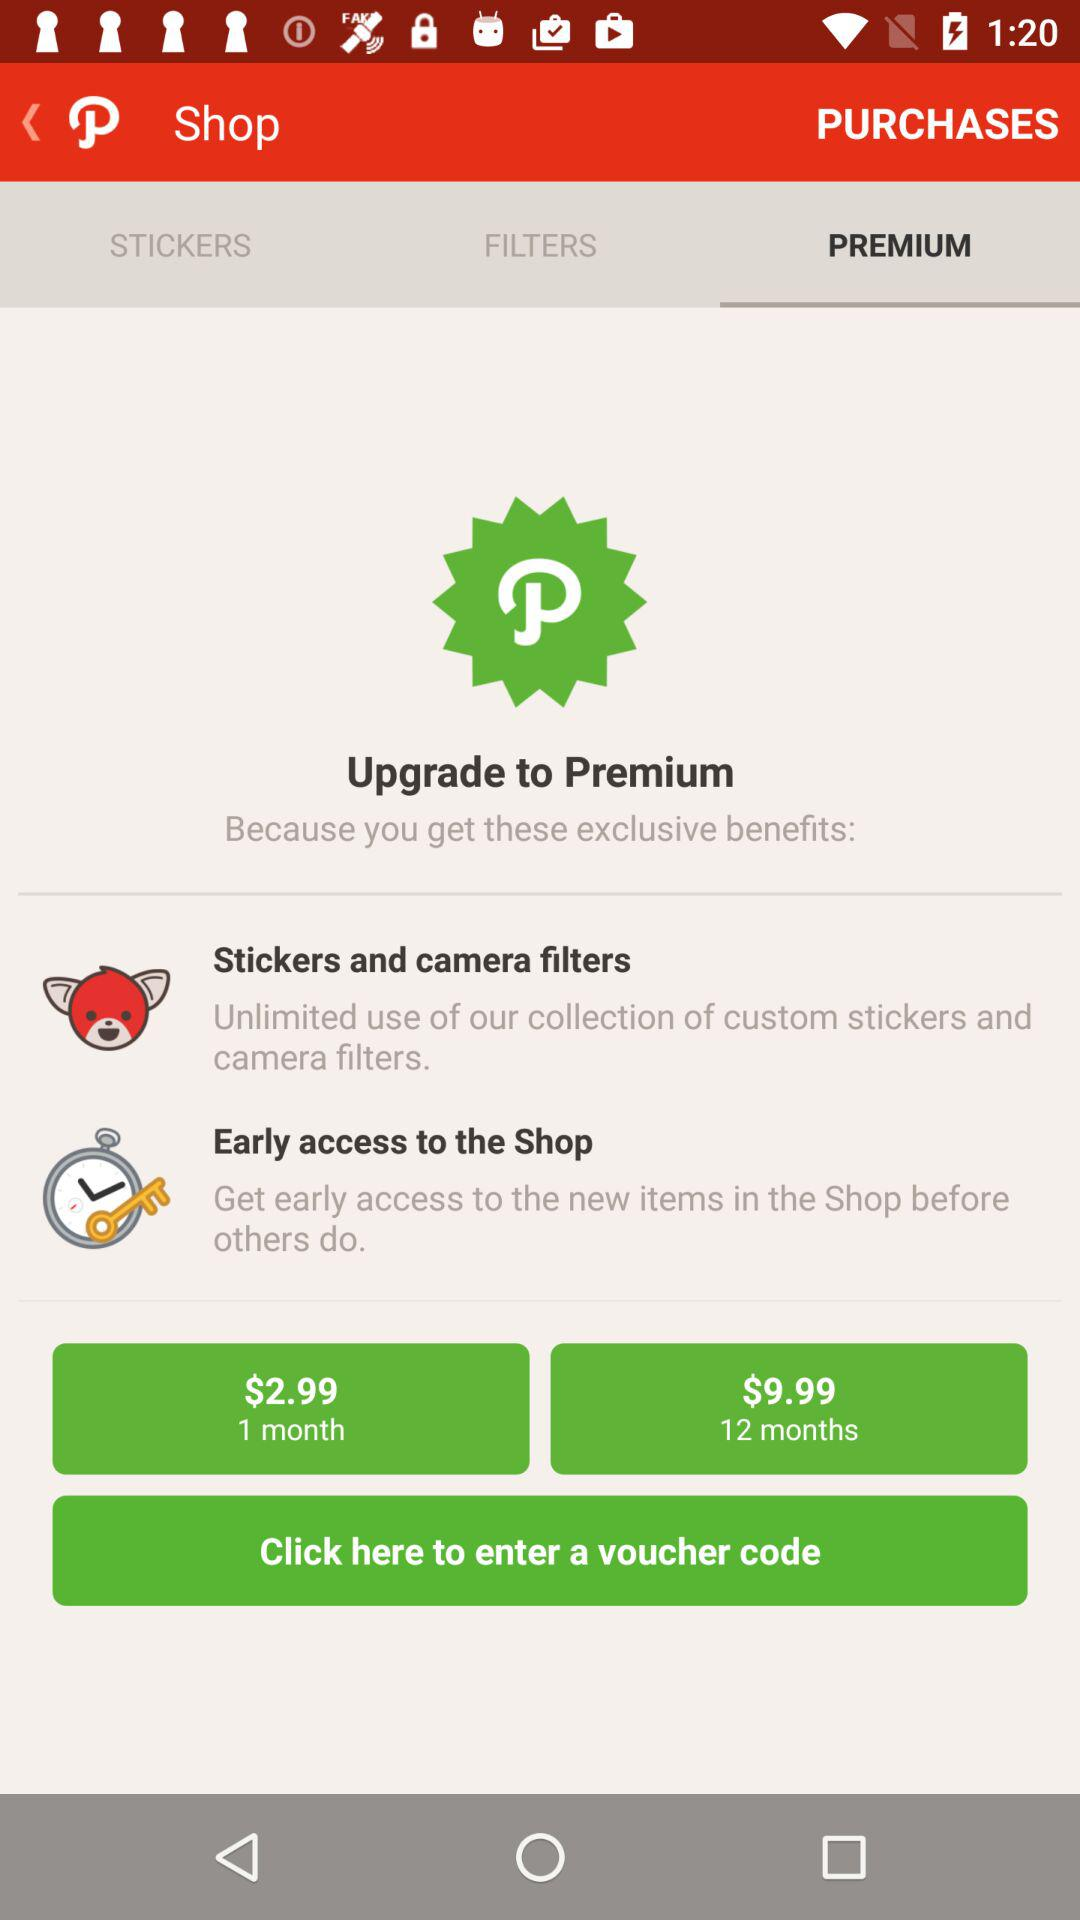How many benefits are there in the Premium upgrade?
Answer the question using a single word or phrase. 2 